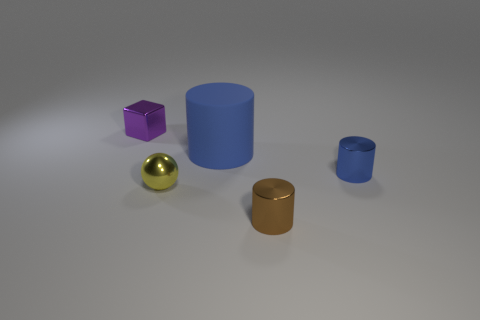There is a blue cylinder that is left of the blue cylinder on the right side of the big object; what is its size?
Offer a terse response. Large. How many small spheres have the same color as the big rubber object?
Provide a succinct answer. 0. There is a blue thing on the right side of the brown object in front of the big blue rubber cylinder; what is its shape?
Your answer should be very brief. Cylinder. What number of small purple things have the same material as the tiny yellow thing?
Make the answer very short. 1. There is a tiny cylinder on the left side of the blue metal object; what is it made of?
Offer a very short reply. Metal. There is a blue thing that is right of the blue cylinder left of the blue object in front of the large matte object; what shape is it?
Your answer should be compact. Cylinder. Does the small object behind the matte cylinder have the same color as the cylinder that is behind the blue metal cylinder?
Give a very brief answer. No. Is the number of tiny blue things that are in front of the tiny brown cylinder less than the number of small brown metallic objects on the left side of the tiny yellow metallic sphere?
Give a very brief answer. No. Is there anything else that has the same shape as the small purple thing?
Your answer should be very brief. No. What color is the other small metallic thing that is the same shape as the brown object?
Provide a short and direct response. Blue. 